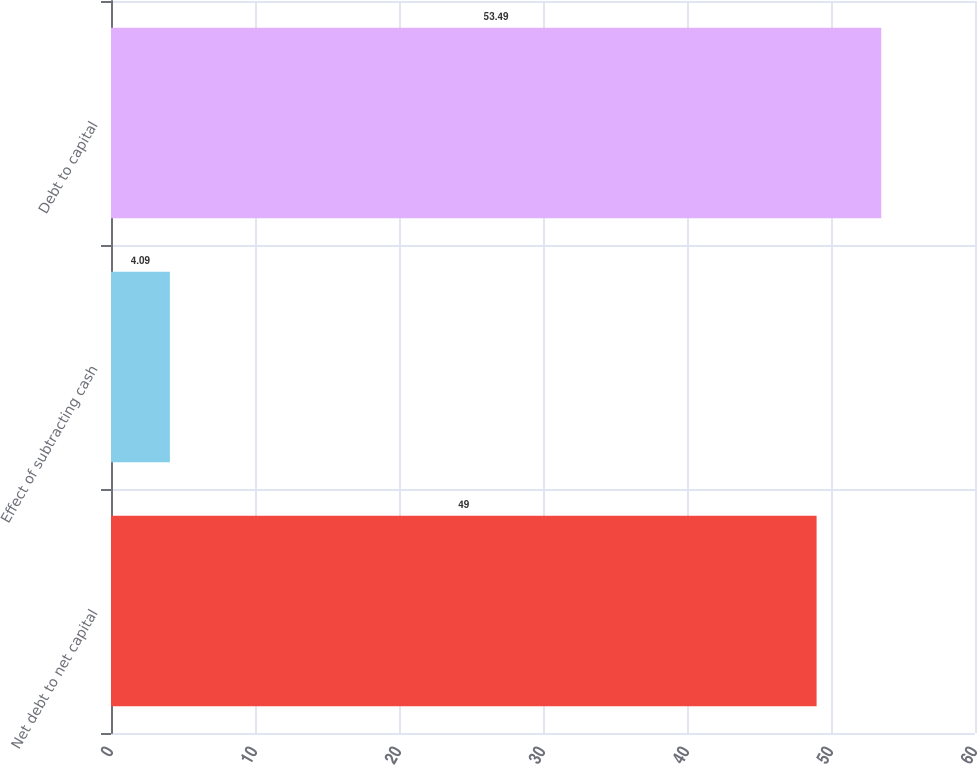Convert chart. <chart><loc_0><loc_0><loc_500><loc_500><bar_chart><fcel>Net debt to net capital<fcel>Effect of subtracting cash<fcel>Debt to capital<nl><fcel>49<fcel>4.09<fcel>53.49<nl></chart> 